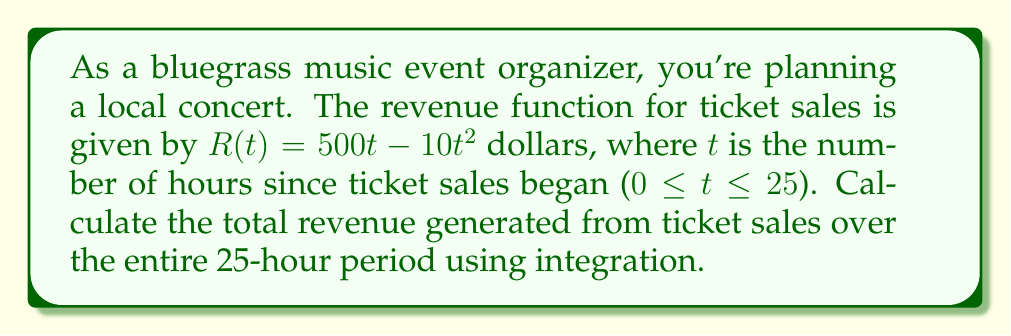Provide a solution to this math problem. To solve this problem, we need to integrate the revenue function over the given time interval. Here's a step-by-step approach:

1. The revenue function is $R(t) = 500t - 10t^2$

2. We need to find the definite integral of this function from $t=0$ to $t=25$:

   $$\int_0^{25} (500t - 10t^2) dt$$

3. Integrate each term separately:
   
   $$\int_0^{25} 500t dt - \int_0^{25} 10t^2 dt$$

4. Antiderivatives:
   
   $$[250t^2]_0^{25} - [\frac{10}{3}t^3]_0^{25}$$

5. Evaluate the antiderivatives at the limits:
   
   $$(250(25)^2 - 250(0)^2) - (\frac{10}{3}(25)^3 - \frac{10}{3}(0)^3)$$

6. Simplify:
   
   $$250(625) - \frac{10}{3}(15625)$$
   
   $$156250 - 52083.33$$

7. Calculate the final result:
   
   $$104166.67$$

Thus, the total revenue generated over the 25-hour period is $104,166.67.
Answer: $104,166.67 